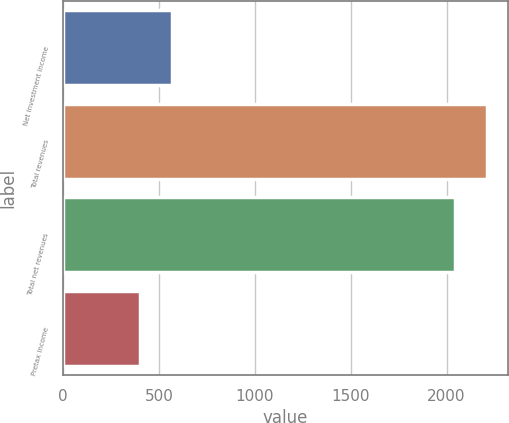<chart> <loc_0><loc_0><loc_500><loc_500><bar_chart><fcel>Net investment income<fcel>Total revenues<fcel>Total net revenues<fcel>Pretax income<nl><fcel>566.5<fcel>2210.5<fcel>2046<fcel>402<nl></chart> 